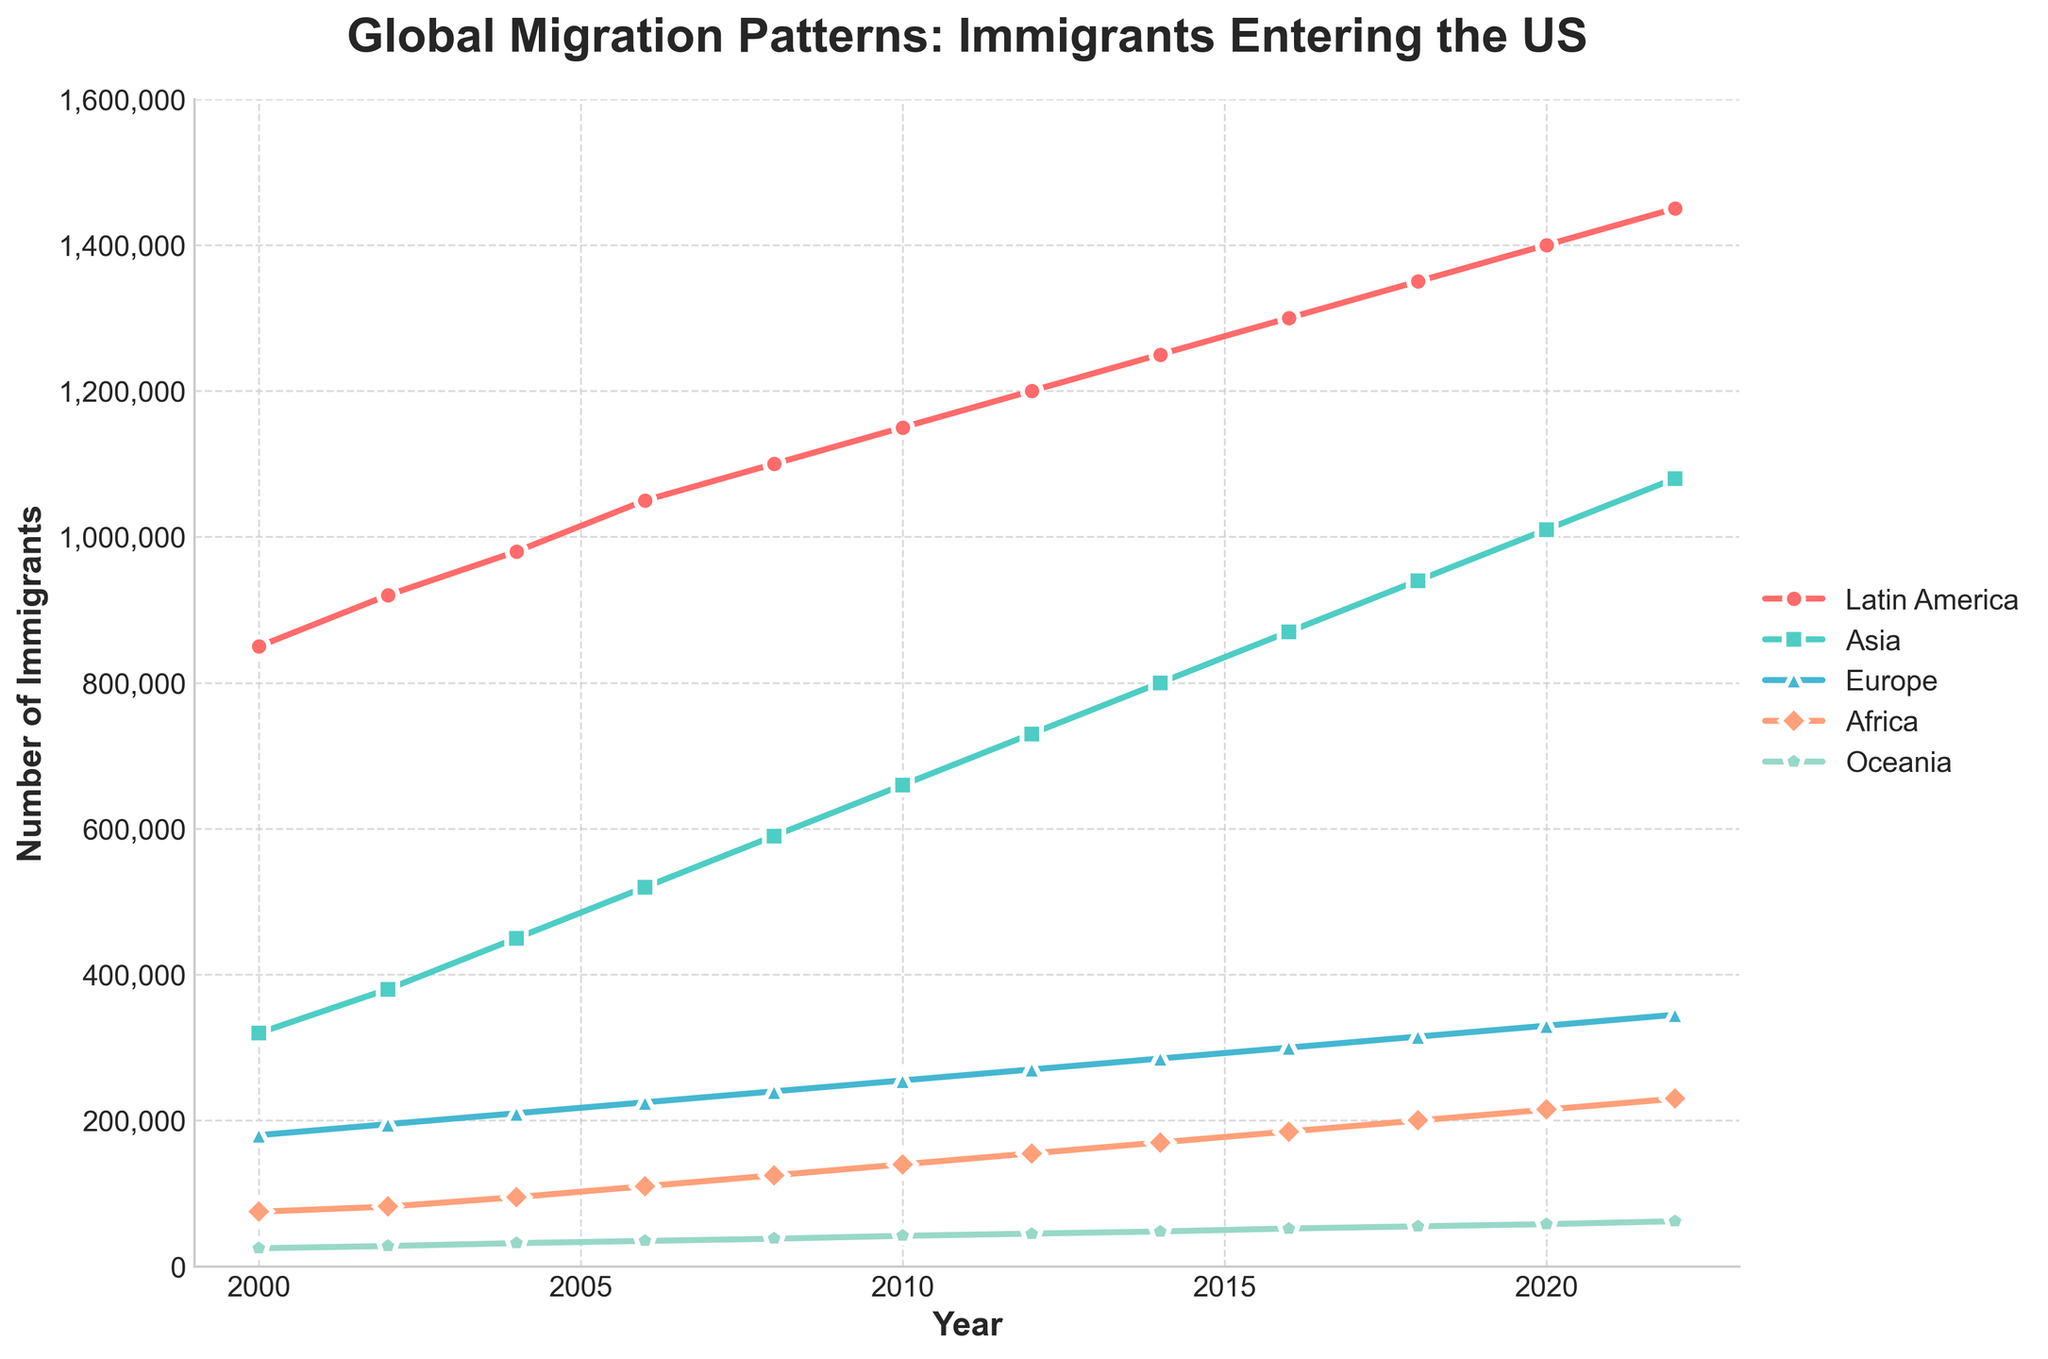Which region had the highest number of immigrants entering the US in 2006? By looking at the figure, find the line corresponding to 2006 and identify the highest point among the regions. For 2006, the line representing Latin America has the highest point.
Answer: Latin America How many more immigrants entered the US from Asia in 2022 compared to 2000? Identify the points for Asia in 2022 and 2000 from the figure. The number of immigrants from Asia in 2022 is 1,080,000, and in 2000, it is 320,000. Calculate the difference: 1,080,000 - 320,000 = 760,000.
Answer: 760,000 What's the average number of immigrants from Europe over the entire period shown? Add the number of immigrants from Europe for all the years and divide by the total number of years. (180,000 + 195,000 + 210,000 + 225,000 + 240,000 + 255,000 + 270,000 + 285,000 + 300,000 + 315,000 + 330,000 + 345,000) / 12 = 265,000.
Answer: 265,000 Which region showed the largest increase in the number of immigrants from 2000 to 2022? Calculate the increase for each region by subtracting the number in 2000 from the number in 2022, then compare the results. Latin America: 1,450,000 - 850,000 = 600,000; Asia: 1,080,000 - 320,000 = 760,000; Europe: 345,000 - 180,000 = 165,000; Africa: 230,000 - 75,000 = 155,000; Oceania: 62,000 - 25,000 = 37,000. The largest increase is for Asia (760,000).
Answer: Asia Which region has the most consistently increasing trend over the years? Visually observe the lines representing each region and check for a consistently upward sloping line without any dips. The line representing Latin America continuously slopes upward.
Answer: Latin America In 2020, which regions had more than 500,000 immigrants entering the US? Identify the points for 2020 on the figure and check which regions are above the 500,000 mark on the vertical axis. Latin America with 1,400,000 and Asia with 1,010,000 are above 500,000.
Answer: Latin America, Asia How do the number of immigrants from Africa and Europe in 2010 compare? Look at the points for both regions in 2010. For Africa, it's 140,000, and for Europe, it's 255,000. Europe has more immigrants than Africa.
Answer: Europe By how much did the number of immigrants from Oceania change between 2004 and 2018? Identify the points for Oceania in 2004 and 2018 and calculate the difference: 55,000 - 32,000 = 23,000.
Answer: 23,000 